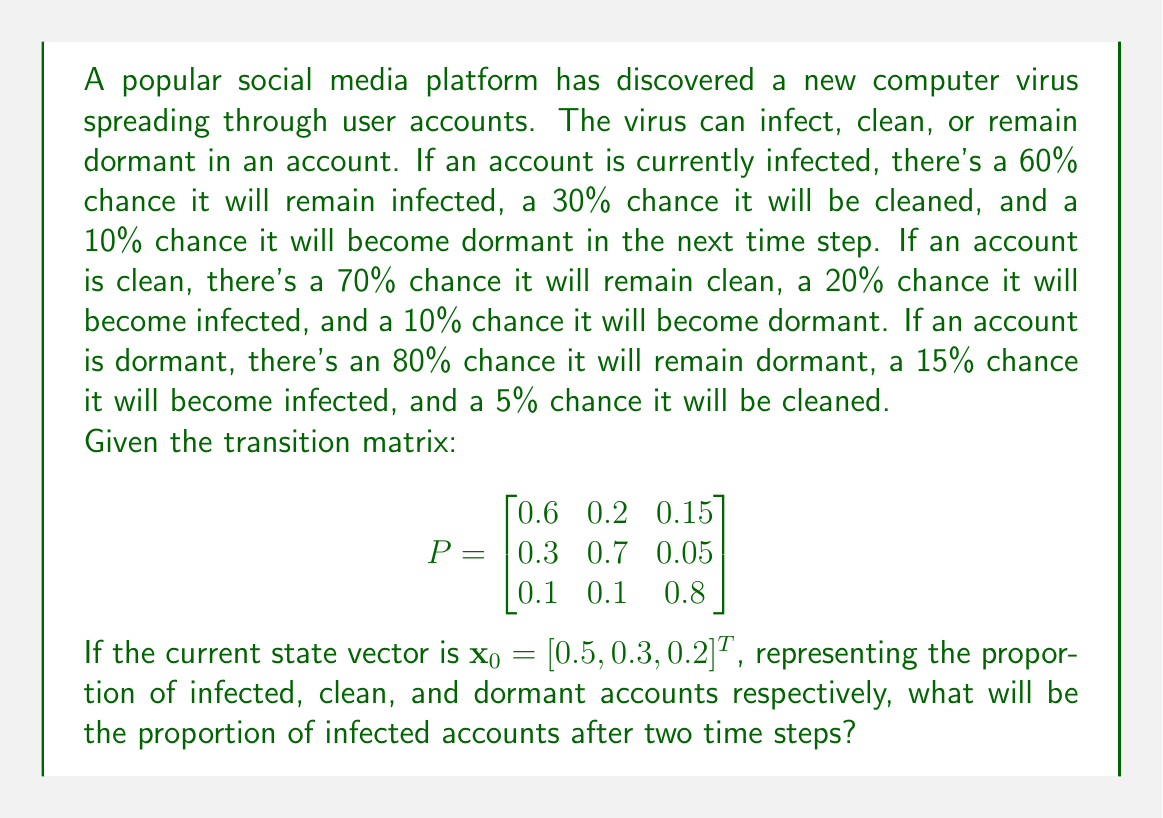Help me with this question. To solve this problem, we'll use the Markov chain equation:

$$\mathbf{x}_n = P^n \mathbf{x}_0$$

Where $\mathbf{x}_n$ is the state vector after $n$ time steps, $P$ is the transition matrix, and $\mathbf{x}_0$ is the initial state vector.

Step 1: Calculate $P^2$
$$P^2 = P \times P = \begin{bmatrix}
0.6 & 0.2 & 0.15 \\
0.3 & 0.7 & 0.05 \\
0.1 & 0.1 & 0.8
\end{bmatrix} \times \begin{bmatrix}
0.6 & 0.2 & 0.15 \\
0.3 & 0.7 & 0.05 \\
0.1 & 0.1 & 0.8
\end{bmatrix}$$

$$P^2 = \begin{bmatrix}
0.45 & 0.23 & 0.32 \\
0.33 & 0.55 & 0.12 \\
0.18 & 0.16 & 0.66
\end{bmatrix}$$

Step 2: Multiply $P^2$ by $\mathbf{x}_0$
$$\mathbf{x}_2 = P^2 \mathbf{x}_0 = \begin{bmatrix}
0.45 & 0.23 & 0.32 \\
0.33 & 0.55 & 0.12 \\
0.18 & 0.16 & 0.66
\end{bmatrix} \times \begin{bmatrix}
0.5 \\
0.3 \\
0.2
\end{bmatrix}$$

$$\mathbf{x}_2 = \begin{bmatrix}
0.45(0.5) + 0.23(0.3) + 0.32(0.2) \\
0.33(0.5) + 0.55(0.3) + 0.12(0.2) \\
0.18(0.5) + 0.16(0.3) + 0.66(0.2)
\end{bmatrix} = \begin{bmatrix}
0.359 \\
0.381 \\
0.260
\end{bmatrix}$$

The first element of $\mathbf{x}_2$ represents the proportion of infected accounts after two time steps.
Answer: 0.359 or 35.9% 